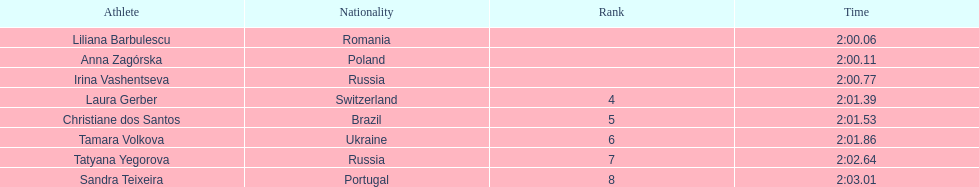In regards to anna zagorska, what was her finishing time? 2:00.11. 